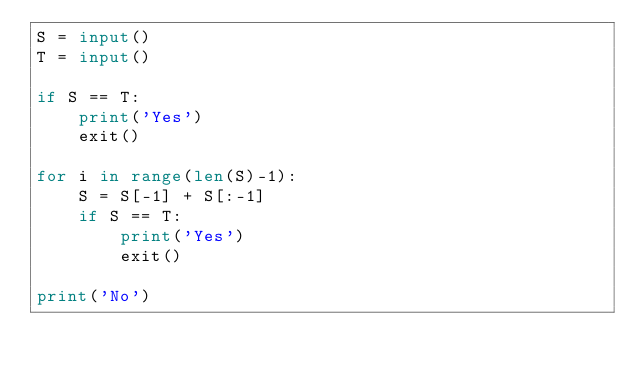<code> <loc_0><loc_0><loc_500><loc_500><_Python_>S = input()
T = input()

if S == T:
    print('Yes')
    exit()

for i in range(len(S)-1):
    S = S[-1] + S[:-1]
    if S == T:
        print('Yes')
        exit()

print('No')</code> 